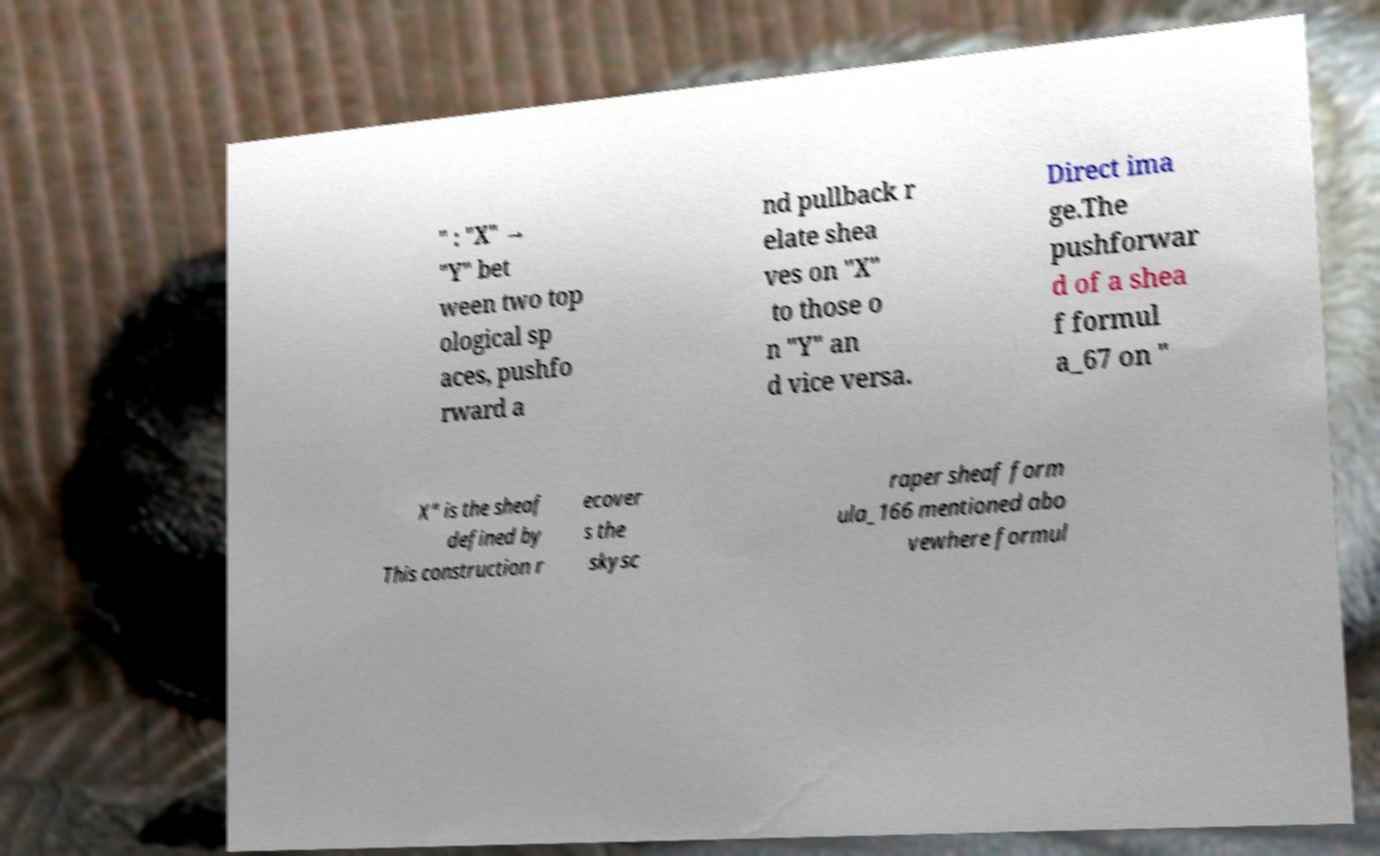I need the written content from this picture converted into text. Can you do that? " : "X" → "Y" bet ween two top ological sp aces, pushfo rward a nd pullback r elate shea ves on "X" to those o n "Y" an d vice versa. Direct ima ge.The pushforwar d of a shea f formul a_67 on " X" is the sheaf defined by This construction r ecover s the skysc raper sheaf form ula_166 mentioned abo vewhere formul 